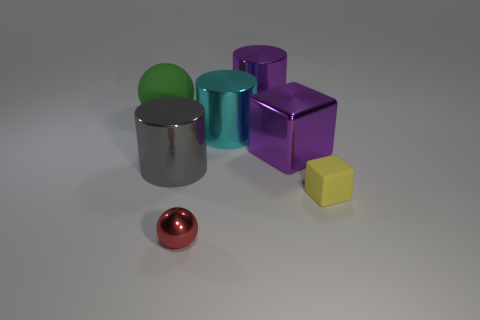Add 2 rubber spheres. How many objects exist? 9 Subtract all spheres. How many objects are left? 5 Subtract 0 yellow balls. How many objects are left? 7 Subtract all cyan balls. Subtract all big gray metal things. How many objects are left? 6 Add 1 small cubes. How many small cubes are left? 2 Add 4 big green objects. How many big green objects exist? 5 